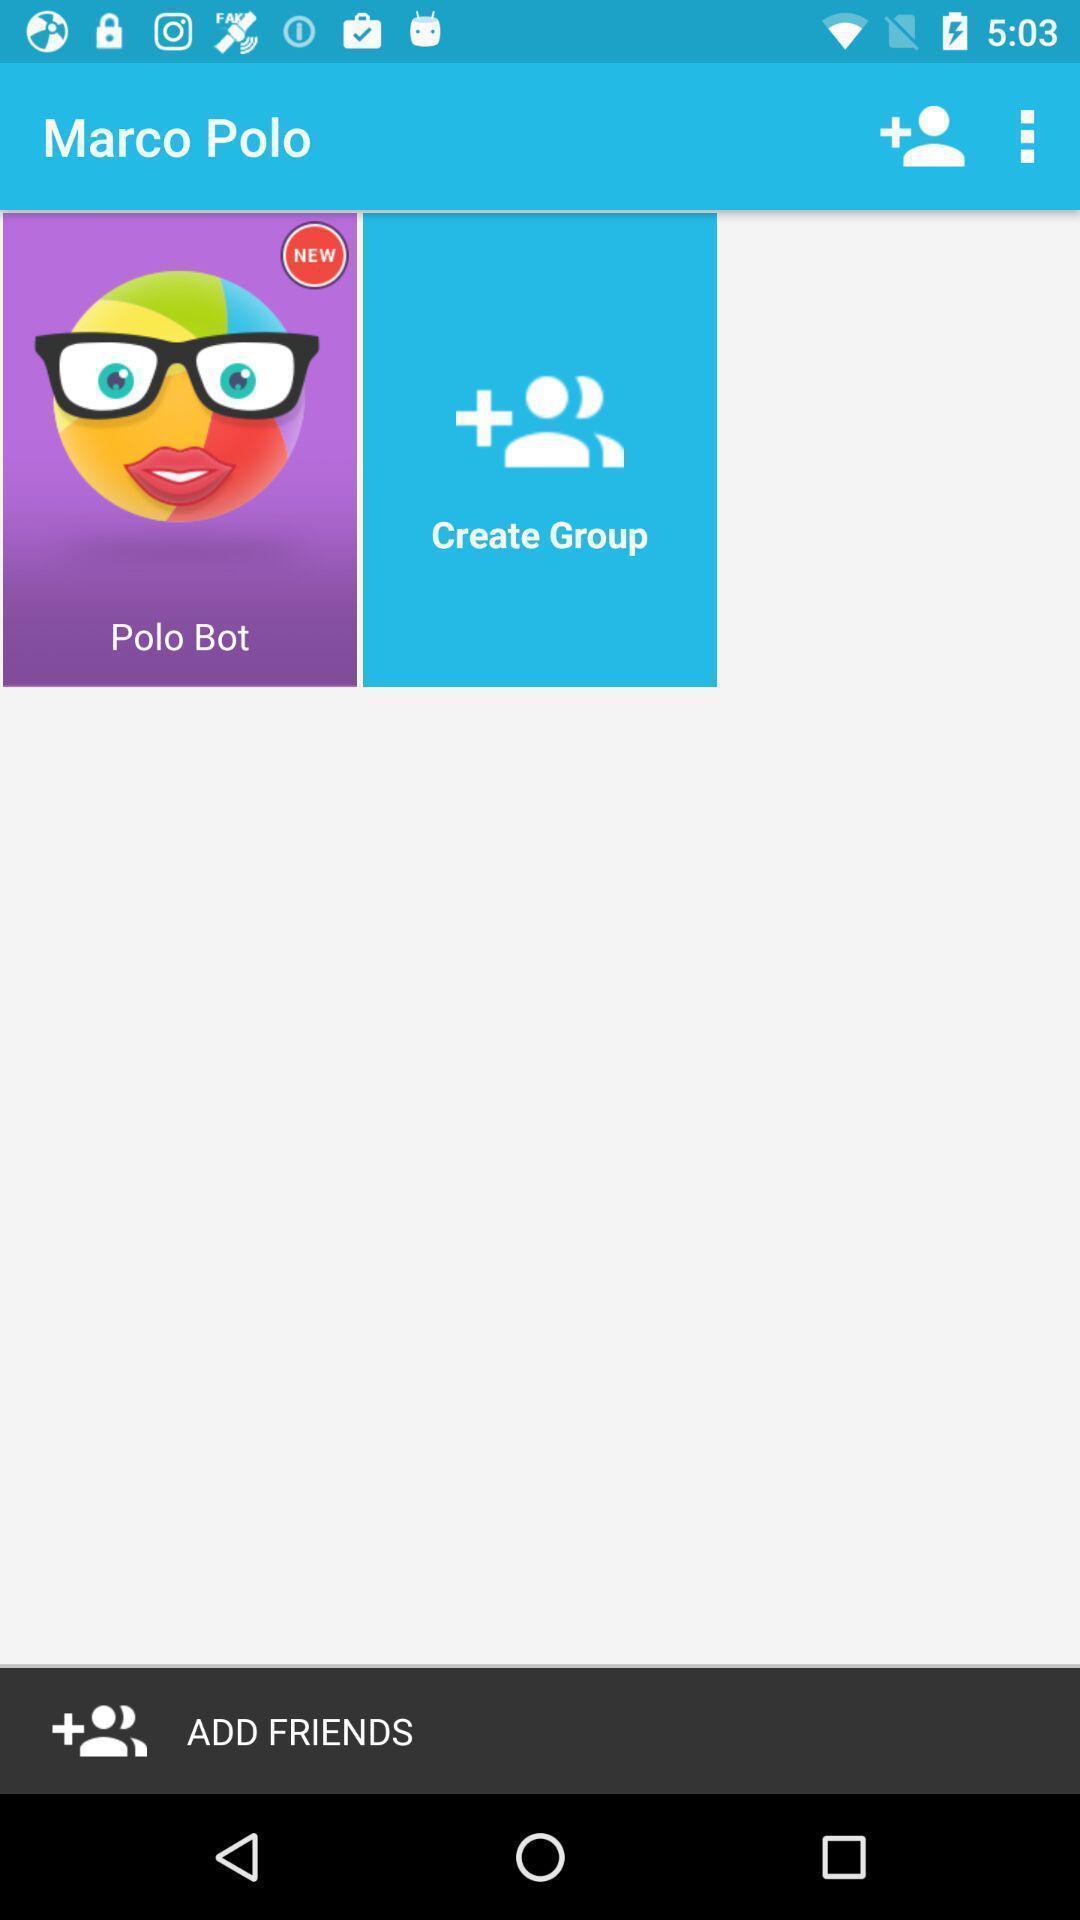Describe the content in this image. Page showing the display page. 